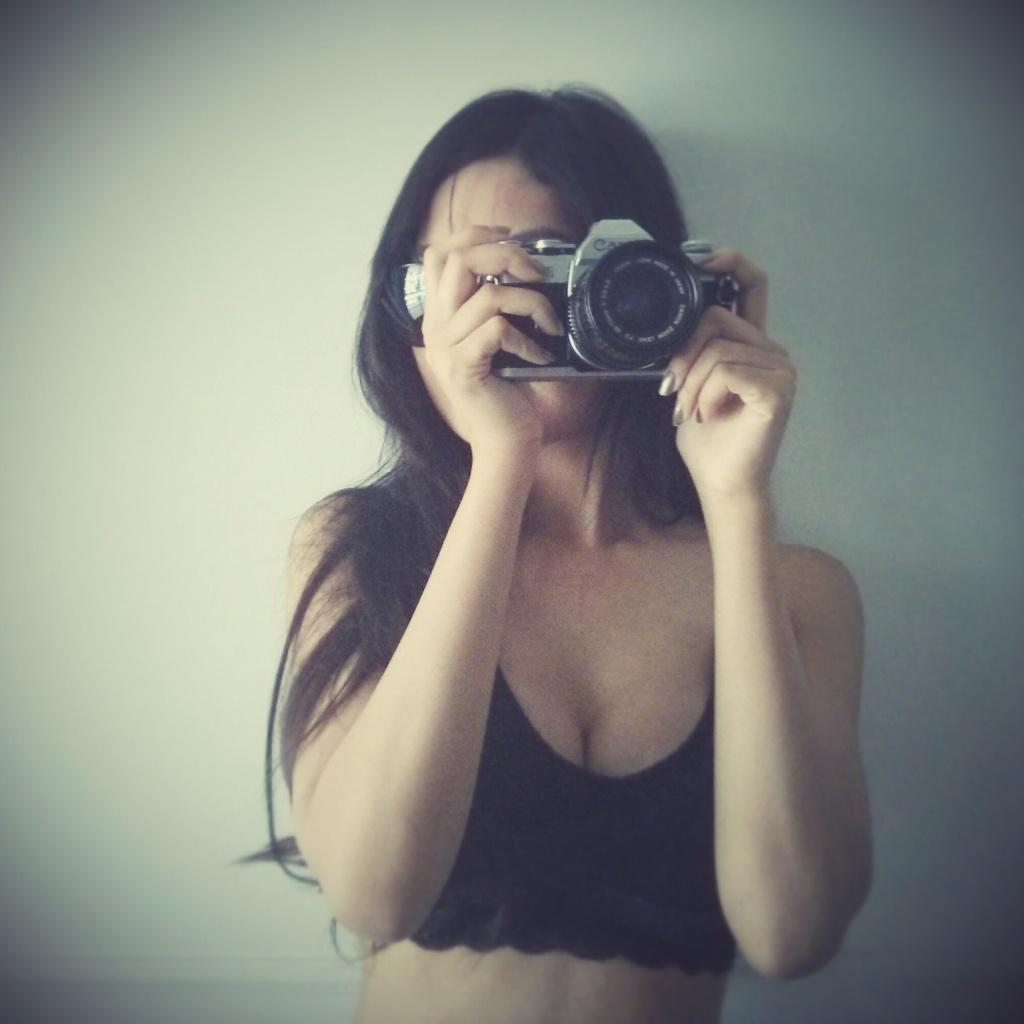Who is the main subject in the image? There is a woman in the image. Where is the woman positioned in the image? The woman is standing in the center of the image. What is the woman holding in the image? The woman is holding a camera. What is the woman doing with the camera? The woman is clicking a picture. How much oatmeal is visible in the image? There is no oatmeal present in the image. What amount of belief does the woman have in the image? The image does not convey any information about the woman's beliefs, so it cannot be determined from the image. 